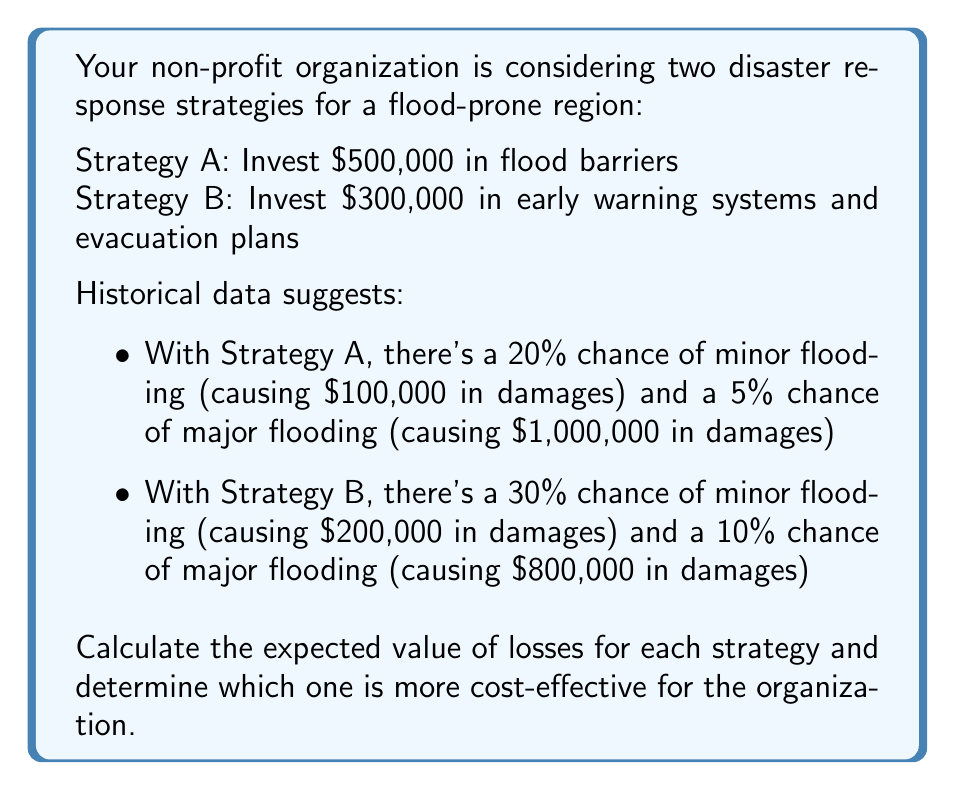Provide a solution to this math problem. Let's approach this step-by-step:

1. Calculate the expected value of losses for Strategy A:

   a. Cost of implementation: $500,000
   b. Expected loss from minor flooding: $100,000 * 0.20 = $20,000
   c. Expected loss from major flooding: $1,000,000 * 0.05 = $50,000
   d. Total expected value of losses:
      $$EV_A = 500,000 + 20,000 + 50,000 = $570,000$$

2. Calculate the expected value of losses for Strategy B:

   a. Cost of implementation: $300,000
   b. Expected loss from minor flooding: $200,000 * 0.30 = $60,000
   c. Expected loss from major flooding: $800,000 * 0.10 = $80,000
   d. Total expected value of losses:
      $$EV_B = 300,000 + 60,000 + 80,000 = $440,000$$

3. Compare the expected values:
   Strategy A: $570,000
   Strategy B: $440,000

4. Determine the more cost-effective strategy:
   Since Strategy B has a lower expected value of losses, it is more cost-effective.

The difference in expected value is:
$$570,000 - 440,000 = $130,000$$

This means that Strategy B is expected to save the organization $130,000 compared to Strategy A.
Answer: Strategy B, with an expected value of losses of $440,000, is more cost-effective. 